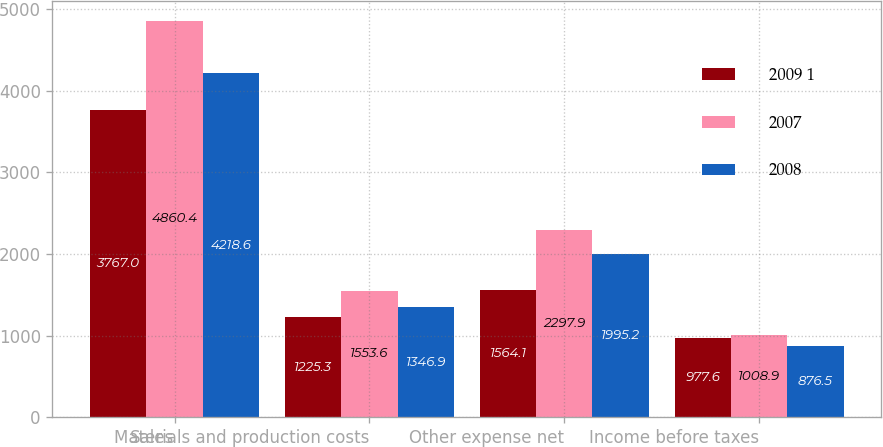Convert chart. <chart><loc_0><loc_0><loc_500><loc_500><stacked_bar_chart><ecel><fcel>Sales<fcel>Materials and production costs<fcel>Other expense net<fcel>Income before taxes<nl><fcel>2009 1<fcel>3767<fcel>1225.3<fcel>1564.1<fcel>977.6<nl><fcel>2007<fcel>4860.4<fcel>1553.6<fcel>2297.9<fcel>1008.9<nl><fcel>2008<fcel>4218.6<fcel>1346.9<fcel>1995.2<fcel>876.5<nl></chart> 